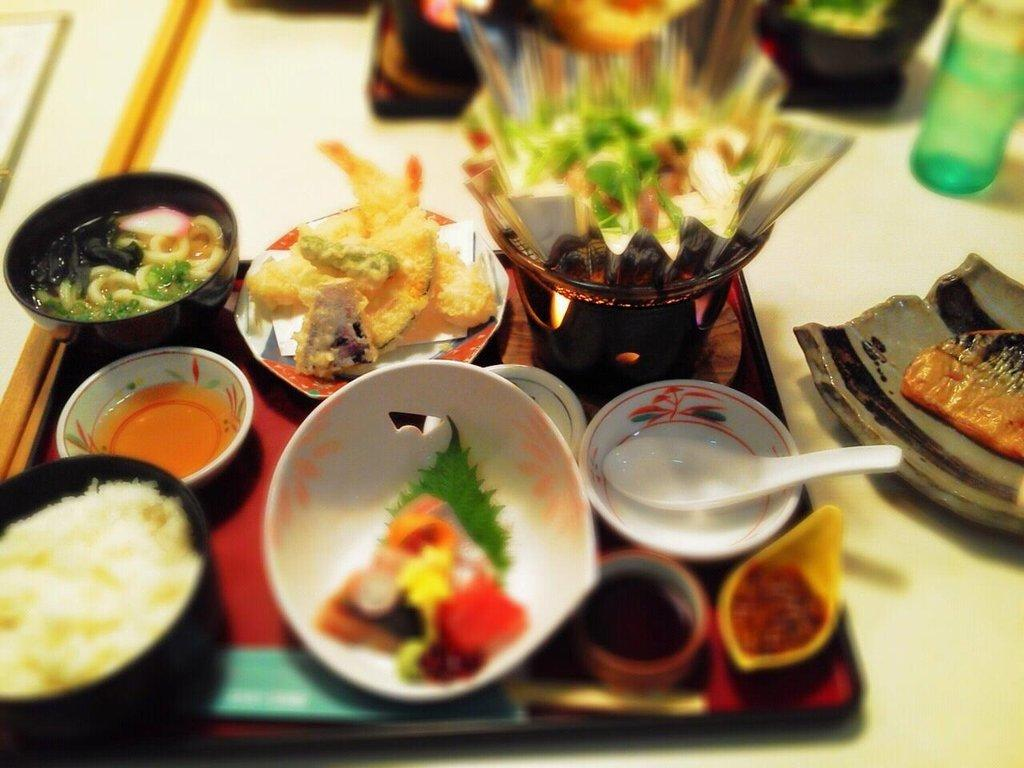What is on the plate that is visible in the image? There is a plate with food items in the image. Where is the plate located in the image? The plate is placed on a table in the image. What type of apple is being used as a part of the computer system in the image? There is no apple or computer system present in the image; it only features a plate with food items placed on a table. 